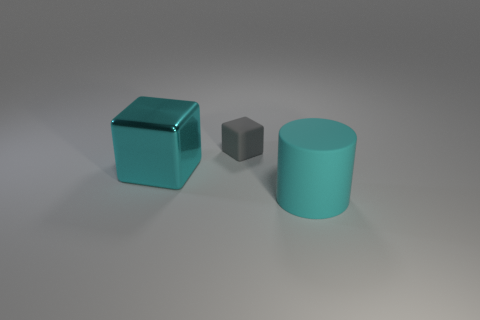Add 3 big red matte balls. How many objects exist? 6 Subtract all cylinders. How many objects are left? 2 Subtract all matte things. Subtract all large red balls. How many objects are left? 1 Add 1 large cyan cubes. How many large cyan cubes are left? 2 Add 2 small gray matte balls. How many small gray matte balls exist? 2 Subtract 0 green blocks. How many objects are left? 3 